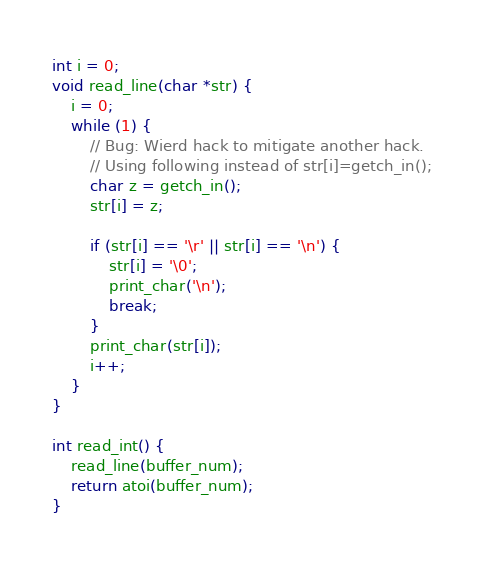<code> <loc_0><loc_0><loc_500><loc_500><_C_>int i = 0;
void read_line(char *str) {
    i = 0;
    while (1) {
        // Bug: Wierd hack to mitigate another hack.
        // Using following instead of str[i]=getch_in();
        char z = getch_in();
        str[i] = z;

        if (str[i] == '\r' || str[i] == '\n') {
            str[i] = '\0';
            print_char('\n');
            break;
        }
        print_char(str[i]);
        i++;
    }
}

int read_int() {
    read_line(buffer_num);
    return atoi(buffer_num);
}</code> 